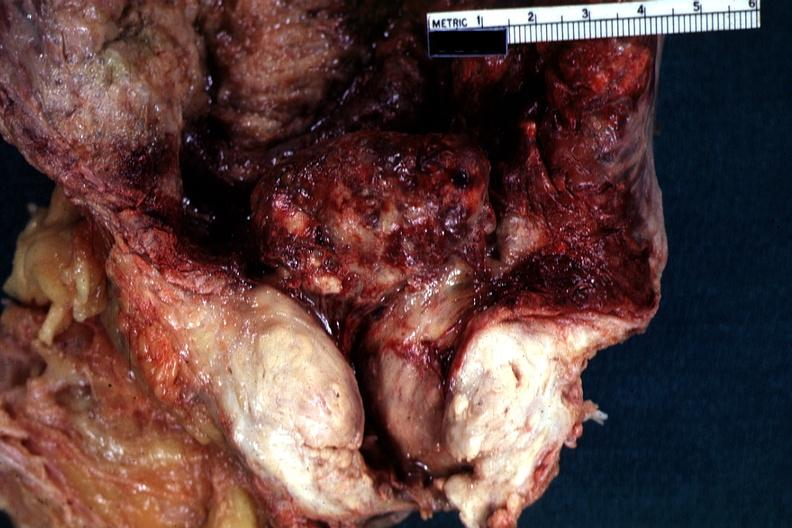s hyperplasia median bar present?
Answer the question using a single word or phrase. Yes 